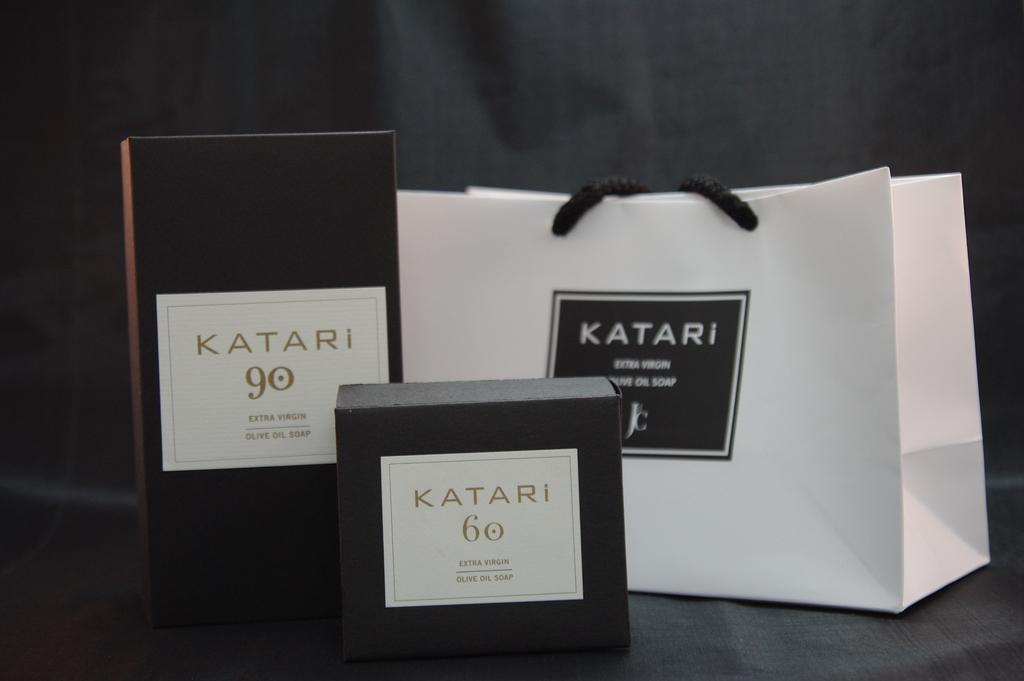<image>
Give a short and clear explanation of the subsequent image. Two containers of Katari Extra Virgin Olive Oil Soap next to a Katari bag. 